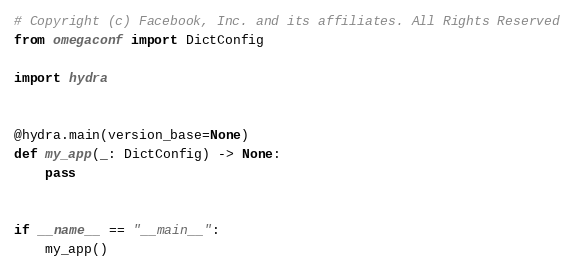<code> <loc_0><loc_0><loc_500><loc_500><_Python_># Copyright (c) Facebook, Inc. and its affiliates. All Rights Reserved
from omegaconf import DictConfig

import hydra


@hydra.main(version_base=None)
def my_app(_: DictConfig) -> None:
    pass


if __name__ == "__main__":
    my_app()
</code> 